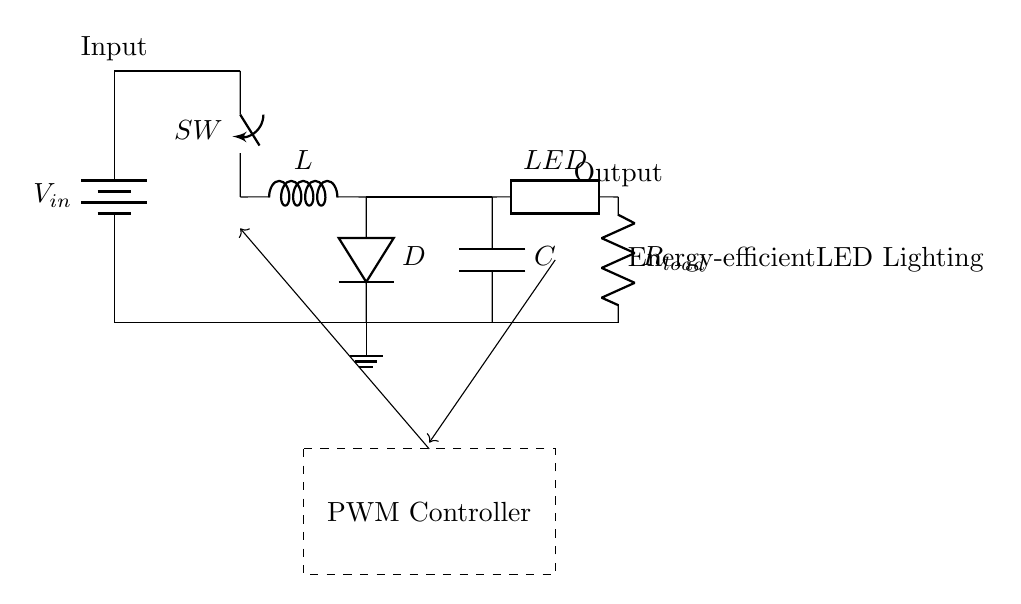What is the input voltage of this circuit? The input voltage is indicated as \( V_{in} \), which is connected to the battery at the start of the circuit.
Answer: \( V_{in} \) What is the function of the switch in the circuit? The switch, labeled \( SW \), is used to control the flow of current through the circuit, allowing or interrupting the power supply to the subsequent components.
Answer: Control current What type of component is represented by \( C \)? \( C \) represents a capacitor, which stores electrical energy in the form of an electric field and helps to smooth out voltage fluctuations in the circuit.
Answer: Capacitor How does the PWM controller impact the circuit? The PWM controller regulates the duty cycle of the voltage supplied to the load, adjusting the brightness of the LED lighting based on the feedback received from the output.
Answer: Regulates brightness What is the role of the inductor in this circuit? The inductor \( L \) stores energy in a magnetic field when current flows through it and releases energy back into the circuit when the current decreases, contributing to the energy efficiency of the power supply.
Answer: Stores energy What is the purpose of the diode \( D \) in this regulator? The diode \( D \) allows current to flow in only one direction, preventing potential backflow that could damage the components and ensuring the charge from the inductor is directed to the load.
Answer: Prevents backflow What kind of load is connected to the output of this circuit? The output is connected to an LED \( LED \) and a resistor \( R_{load} \), which together make up the load intended for energy-efficient lighting.
Answer: LED lighting 